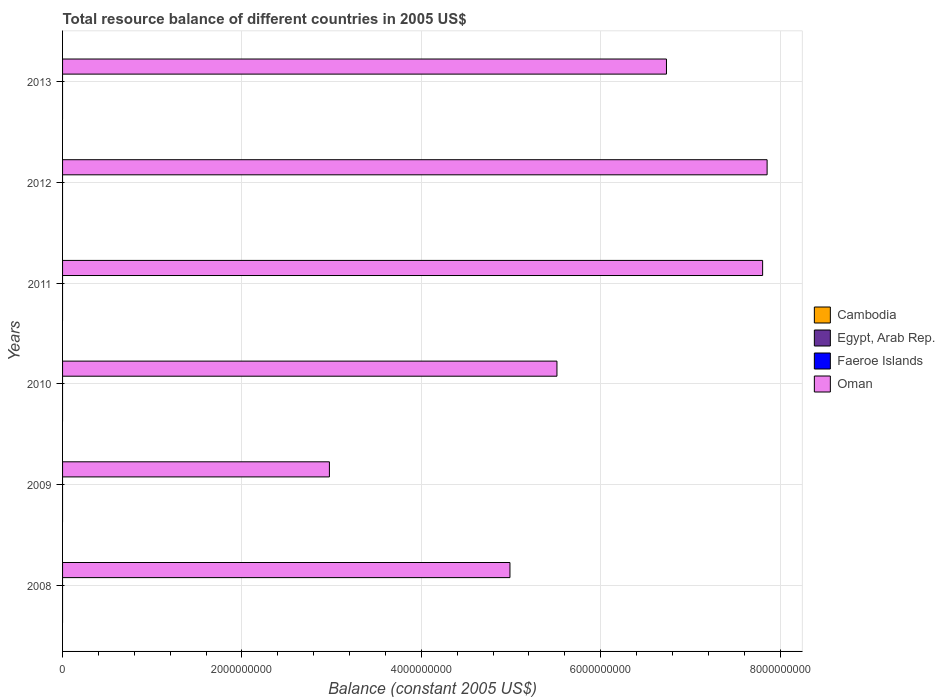How many different coloured bars are there?
Your response must be concise. 1. Are the number of bars per tick equal to the number of legend labels?
Offer a terse response. No. How many bars are there on the 2nd tick from the top?
Your response must be concise. 1. How many bars are there on the 5th tick from the bottom?
Keep it short and to the point. 1. What is the label of the 6th group of bars from the top?
Provide a short and direct response. 2008. In how many cases, is the number of bars for a given year not equal to the number of legend labels?
Keep it short and to the point. 6. Across all years, what is the maximum total resource balance in Oman?
Provide a succinct answer. 7.86e+09. Across all years, what is the minimum total resource balance in Faeroe Islands?
Offer a terse response. 0. In which year was the total resource balance in Oman maximum?
Give a very brief answer. 2012. What is the total total resource balance in Oman in the graph?
Your response must be concise. 3.59e+1. What is the difference between the total resource balance in Oman in 2009 and that in 2010?
Make the answer very short. -2.54e+09. What is the difference between the total resource balance in Egypt, Arab Rep. in 2008 and the total resource balance in Cambodia in 2012?
Offer a very short reply. 0. What is the average total resource balance in Cambodia per year?
Provide a succinct answer. 0. In how many years, is the total resource balance in Cambodia greater than 6800000000 US$?
Offer a very short reply. 0. Is the total resource balance in Oman in 2008 less than that in 2011?
Offer a terse response. Yes. What is the difference between the highest and the second highest total resource balance in Oman?
Make the answer very short. 5.00e+07. What is the difference between the highest and the lowest total resource balance in Oman?
Provide a short and direct response. 4.88e+09. Is the sum of the total resource balance in Oman in 2008 and 2011 greater than the maximum total resource balance in Egypt, Arab Rep. across all years?
Offer a terse response. Yes. Is it the case that in every year, the sum of the total resource balance in Egypt, Arab Rep. and total resource balance in Faeroe Islands is greater than the total resource balance in Oman?
Give a very brief answer. No. Are all the bars in the graph horizontal?
Your answer should be very brief. Yes. What is the difference between two consecutive major ticks on the X-axis?
Make the answer very short. 2.00e+09. Are the values on the major ticks of X-axis written in scientific E-notation?
Your answer should be compact. No. Does the graph contain any zero values?
Provide a short and direct response. Yes. Where does the legend appear in the graph?
Provide a succinct answer. Center right. What is the title of the graph?
Make the answer very short. Total resource balance of different countries in 2005 US$. What is the label or title of the X-axis?
Provide a succinct answer. Balance (constant 2005 US$). What is the Balance (constant 2005 US$) in Egypt, Arab Rep. in 2008?
Ensure brevity in your answer.  0. What is the Balance (constant 2005 US$) in Faeroe Islands in 2008?
Your response must be concise. 0. What is the Balance (constant 2005 US$) in Oman in 2008?
Your answer should be very brief. 4.99e+09. What is the Balance (constant 2005 US$) of Egypt, Arab Rep. in 2009?
Provide a short and direct response. 0. What is the Balance (constant 2005 US$) of Faeroe Islands in 2009?
Provide a succinct answer. 0. What is the Balance (constant 2005 US$) in Oman in 2009?
Keep it short and to the point. 2.98e+09. What is the Balance (constant 2005 US$) of Cambodia in 2010?
Your response must be concise. 0. What is the Balance (constant 2005 US$) of Egypt, Arab Rep. in 2010?
Your answer should be compact. 0. What is the Balance (constant 2005 US$) of Faeroe Islands in 2010?
Your answer should be compact. 0. What is the Balance (constant 2005 US$) in Oman in 2010?
Your answer should be compact. 5.51e+09. What is the Balance (constant 2005 US$) in Cambodia in 2011?
Provide a short and direct response. 0. What is the Balance (constant 2005 US$) in Egypt, Arab Rep. in 2011?
Offer a very short reply. 0. What is the Balance (constant 2005 US$) of Oman in 2011?
Your response must be concise. 7.80e+09. What is the Balance (constant 2005 US$) in Cambodia in 2012?
Your answer should be very brief. 0. What is the Balance (constant 2005 US$) of Egypt, Arab Rep. in 2012?
Your answer should be compact. 0. What is the Balance (constant 2005 US$) of Faeroe Islands in 2012?
Ensure brevity in your answer.  0. What is the Balance (constant 2005 US$) of Oman in 2012?
Provide a succinct answer. 7.86e+09. What is the Balance (constant 2005 US$) in Cambodia in 2013?
Provide a short and direct response. 0. What is the Balance (constant 2005 US$) in Oman in 2013?
Provide a succinct answer. 6.73e+09. Across all years, what is the maximum Balance (constant 2005 US$) of Oman?
Your answer should be compact. 7.86e+09. Across all years, what is the minimum Balance (constant 2005 US$) in Oman?
Give a very brief answer. 2.98e+09. What is the total Balance (constant 2005 US$) of Cambodia in the graph?
Keep it short and to the point. 0. What is the total Balance (constant 2005 US$) in Egypt, Arab Rep. in the graph?
Your response must be concise. 0. What is the total Balance (constant 2005 US$) in Faeroe Islands in the graph?
Ensure brevity in your answer.  0. What is the total Balance (constant 2005 US$) of Oman in the graph?
Keep it short and to the point. 3.59e+1. What is the difference between the Balance (constant 2005 US$) in Oman in 2008 and that in 2009?
Ensure brevity in your answer.  2.01e+09. What is the difference between the Balance (constant 2005 US$) of Oman in 2008 and that in 2010?
Give a very brief answer. -5.24e+08. What is the difference between the Balance (constant 2005 US$) in Oman in 2008 and that in 2011?
Your response must be concise. -2.82e+09. What is the difference between the Balance (constant 2005 US$) in Oman in 2008 and that in 2012?
Your answer should be compact. -2.87e+09. What is the difference between the Balance (constant 2005 US$) of Oman in 2008 and that in 2013?
Ensure brevity in your answer.  -1.74e+09. What is the difference between the Balance (constant 2005 US$) of Oman in 2009 and that in 2010?
Provide a succinct answer. -2.54e+09. What is the difference between the Balance (constant 2005 US$) in Oman in 2009 and that in 2011?
Your answer should be compact. -4.83e+09. What is the difference between the Balance (constant 2005 US$) in Oman in 2009 and that in 2012?
Offer a very short reply. -4.88e+09. What is the difference between the Balance (constant 2005 US$) in Oman in 2009 and that in 2013?
Ensure brevity in your answer.  -3.76e+09. What is the difference between the Balance (constant 2005 US$) of Oman in 2010 and that in 2011?
Offer a very short reply. -2.29e+09. What is the difference between the Balance (constant 2005 US$) in Oman in 2010 and that in 2012?
Provide a succinct answer. -2.34e+09. What is the difference between the Balance (constant 2005 US$) in Oman in 2010 and that in 2013?
Your response must be concise. -1.22e+09. What is the difference between the Balance (constant 2005 US$) in Oman in 2011 and that in 2012?
Provide a succinct answer. -5.00e+07. What is the difference between the Balance (constant 2005 US$) in Oman in 2011 and that in 2013?
Your answer should be very brief. 1.07e+09. What is the difference between the Balance (constant 2005 US$) of Oman in 2012 and that in 2013?
Offer a very short reply. 1.12e+09. What is the average Balance (constant 2005 US$) of Oman per year?
Give a very brief answer. 5.98e+09. What is the ratio of the Balance (constant 2005 US$) in Oman in 2008 to that in 2009?
Give a very brief answer. 1.68. What is the ratio of the Balance (constant 2005 US$) in Oman in 2008 to that in 2010?
Your answer should be very brief. 0.9. What is the ratio of the Balance (constant 2005 US$) in Oman in 2008 to that in 2011?
Offer a very short reply. 0.64. What is the ratio of the Balance (constant 2005 US$) of Oman in 2008 to that in 2012?
Ensure brevity in your answer.  0.64. What is the ratio of the Balance (constant 2005 US$) in Oman in 2008 to that in 2013?
Offer a terse response. 0.74. What is the ratio of the Balance (constant 2005 US$) of Oman in 2009 to that in 2010?
Provide a short and direct response. 0.54. What is the ratio of the Balance (constant 2005 US$) of Oman in 2009 to that in 2011?
Give a very brief answer. 0.38. What is the ratio of the Balance (constant 2005 US$) of Oman in 2009 to that in 2012?
Make the answer very short. 0.38. What is the ratio of the Balance (constant 2005 US$) in Oman in 2009 to that in 2013?
Give a very brief answer. 0.44. What is the ratio of the Balance (constant 2005 US$) of Oman in 2010 to that in 2011?
Offer a very short reply. 0.71. What is the ratio of the Balance (constant 2005 US$) of Oman in 2010 to that in 2012?
Ensure brevity in your answer.  0.7. What is the ratio of the Balance (constant 2005 US$) in Oman in 2010 to that in 2013?
Your response must be concise. 0.82. What is the ratio of the Balance (constant 2005 US$) in Oman in 2011 to that in 2013?
Keep it short and to the point. 1.16. What is the ratio of the Balance (constant 2005 US$) in Oman in 2012 to that in 2013?
Keep it short and to the point. 1.17. What is the difference between the highest and the lowest Balance (constant 2005 US$) of Oman?
Ensure brevity in your answer.  4.88e+09. 